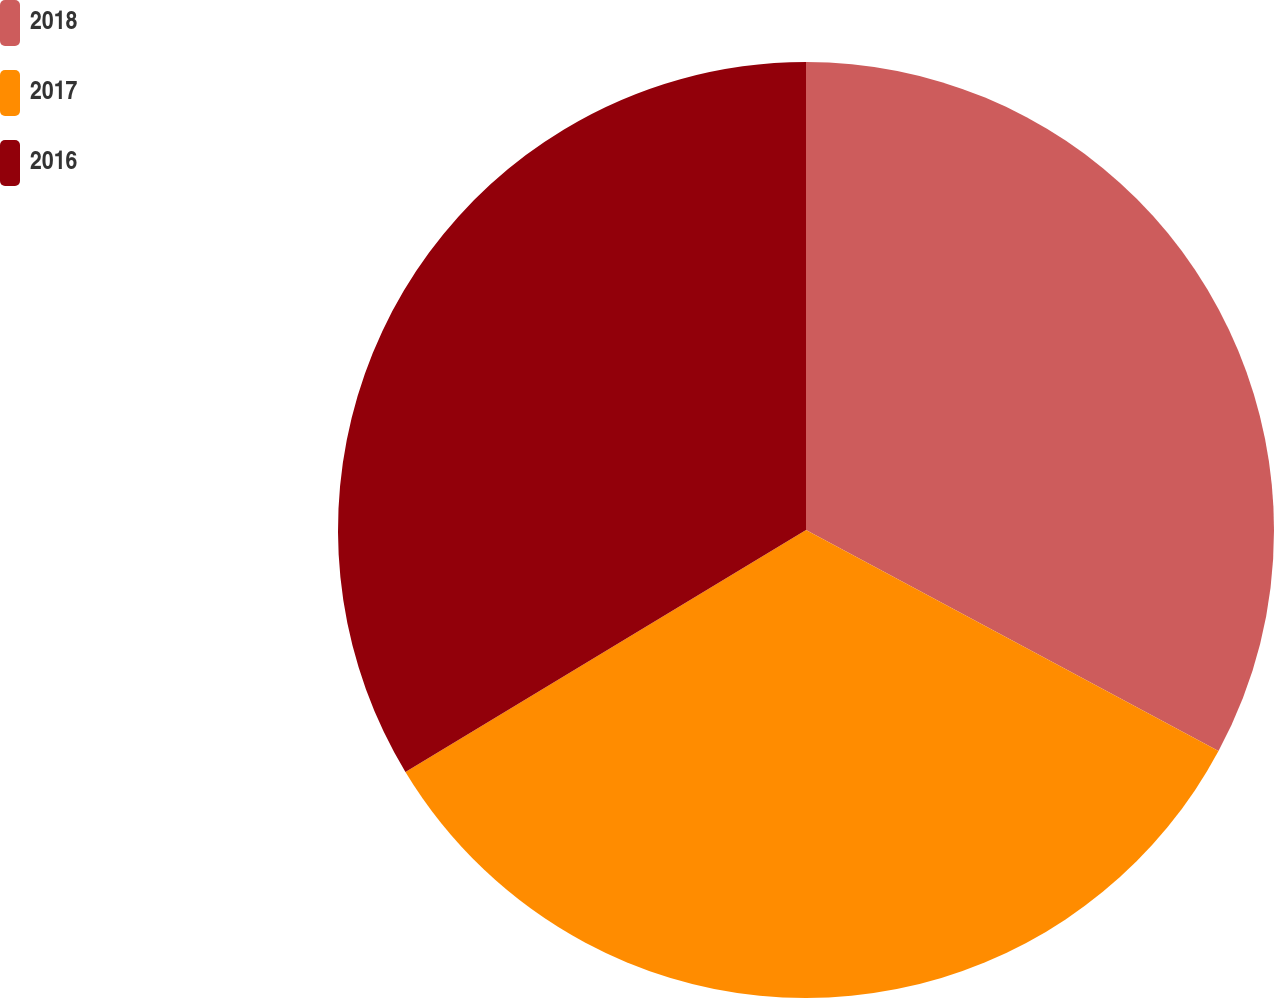<chart> <loc_0><loc_0><loc_500><loc_500><pie_chart><fcel>2018<fcel>2017<fcel>2016<nl><fcel>32.83%<fcel>33.52%<fcel>33.65%<nl></chart> 